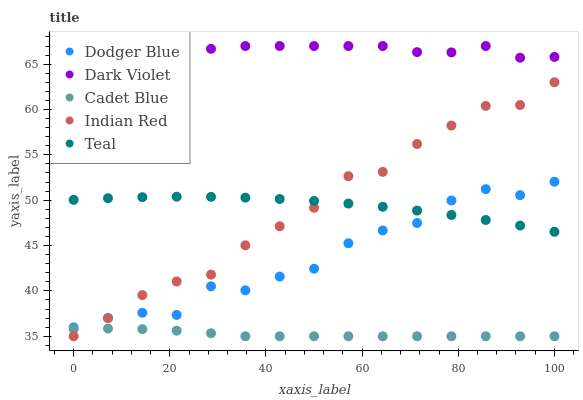Does Cadet Blue have the minimum area under the curve?
Answer yes or no. Yes. Does Dark Violet have the maximum area under the curve?
Answer yes or no. Yes. Does Dodger Blue have the minimum area under the curve?
Answer yes or no. No. Does Dodger Blue have the maximum area under the curve?
Answer yes or no. No. Is Cadet Blue the smoothest?
Answer yes or no. Yes. Is Dodger Blue the roughest?
Answer yes or no. Yes. Is Dodger Blue the smoothest?
Answer yes or no. No. Is Cadet Blue the roughest?
Answer yes or no. No. Does Cadet Blue have the lowest value?
Answer yes or no. Yes. Does Dodger Blue have the lowest value?
Answer yes or no. No. Does Dark Violet have the highest value?
Answer yes or no. Yes. Does Dodger Blue have the highest value?
Answer yes or no. No. Is Teal less than Dark Violet?
Answer yes or no. Yes. Is Teal greater than Cadet Blue?
Answer yes or no. Yes. Does Cadet Blue intersect Indian Red?
Answer yes or no. Yes. Is Cadet Blue less than Indian Red?
Answer yes or no. No. Is Cadet Blue greater than Indian Red?
Answer yes or no. No. Does Teal intersect Dark Violet?
Answer yes or no. No. 